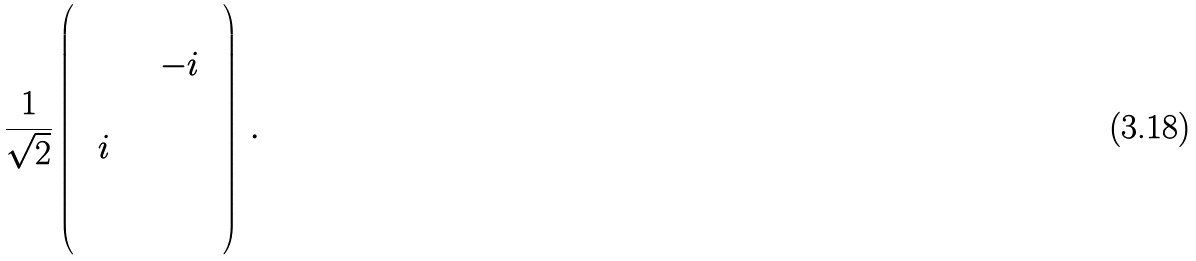Convert formula to latex. <formula><loc_0><loc_0><loc_500><loc_500>\frac { 1 } { \sqrt { 2 } } \left ( \begin{array} { c c c c c c } & & & & & \\ & & & & - i & \\ & & & & & \\ & i & & & & \\ & & & & & \\ & & & & & \end{array} \right ) \, .</formula> 